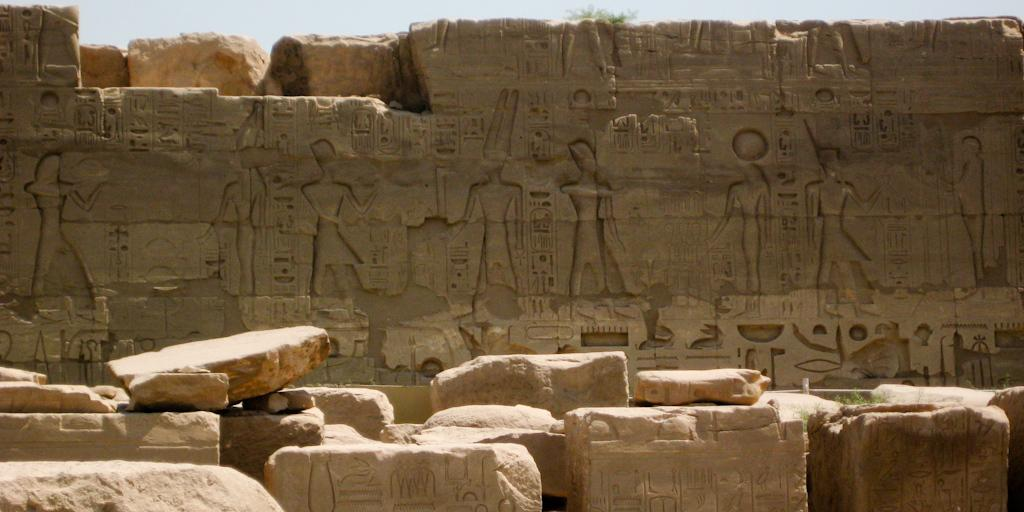What type of artwork can be seen in the image? There are sculptures on the walls and rocks in the image. What can be seen in the background of the image? The sky is visible in the background of the image. How many friends are depicted in the sculptures on the rocks in the image? There are no friends depicted in the sculptures on the rocks in the image, as they are inanimate objects. 